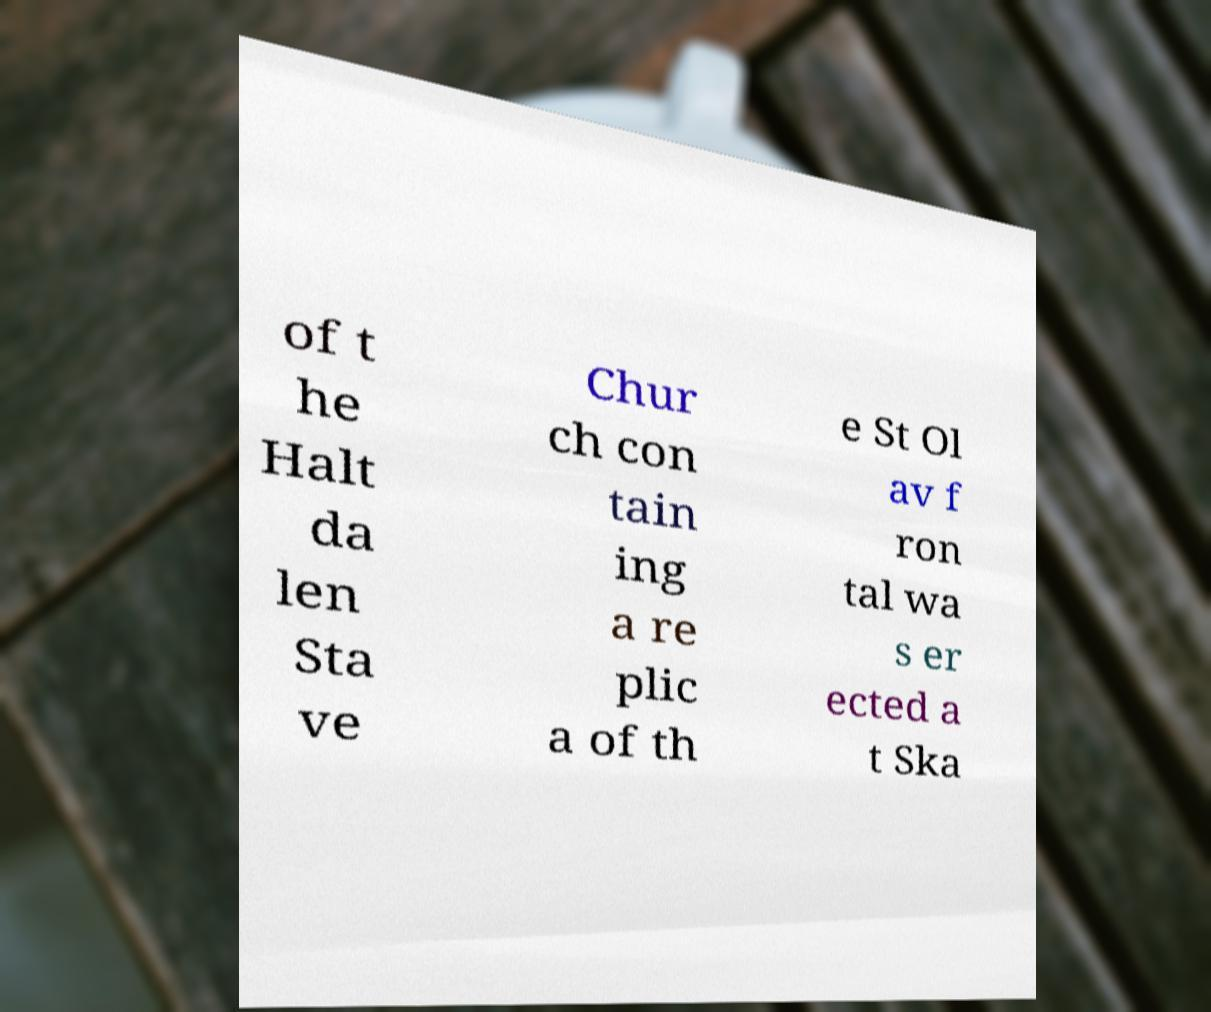What messages or text are displayed in this image? I need them in a readable, typed format. of t he Halt da len Sta ve Chur ch con tain ing a re plic a of th e St Ol av f ron tal wa s er ected a t Ska 